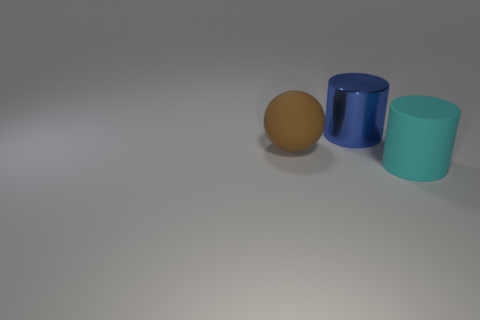Can you describe the texture and material of the objects in the image? The objects in the image appear to have different textures. The brown object on the left seems to have a matte, slightly rough texture, consistent with that of an eggshell. In contrast, the blue and green cylinders in the center and right appear to be made of a smoother material, possibly plastic or painted metal, with a reflective surface that catches the light. Based on their materials, what could the uses of these objects be? Assuming the brown object is an egg, its use would be primarily culinary, likely in cooking or baking. The blue and green cylinders could serve as vessels or containers, potentially for storing items or as parts of a larger mechanical device, depending on their actual sizes and context. 